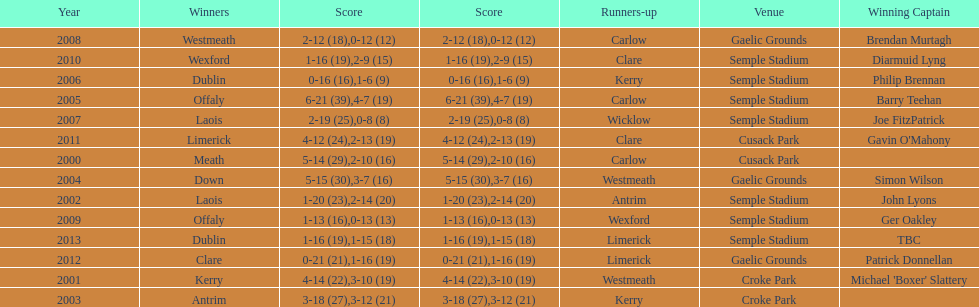Who was the successful captain when the competition was last held at the gaelic grounds site? Patrick Donnellan. 